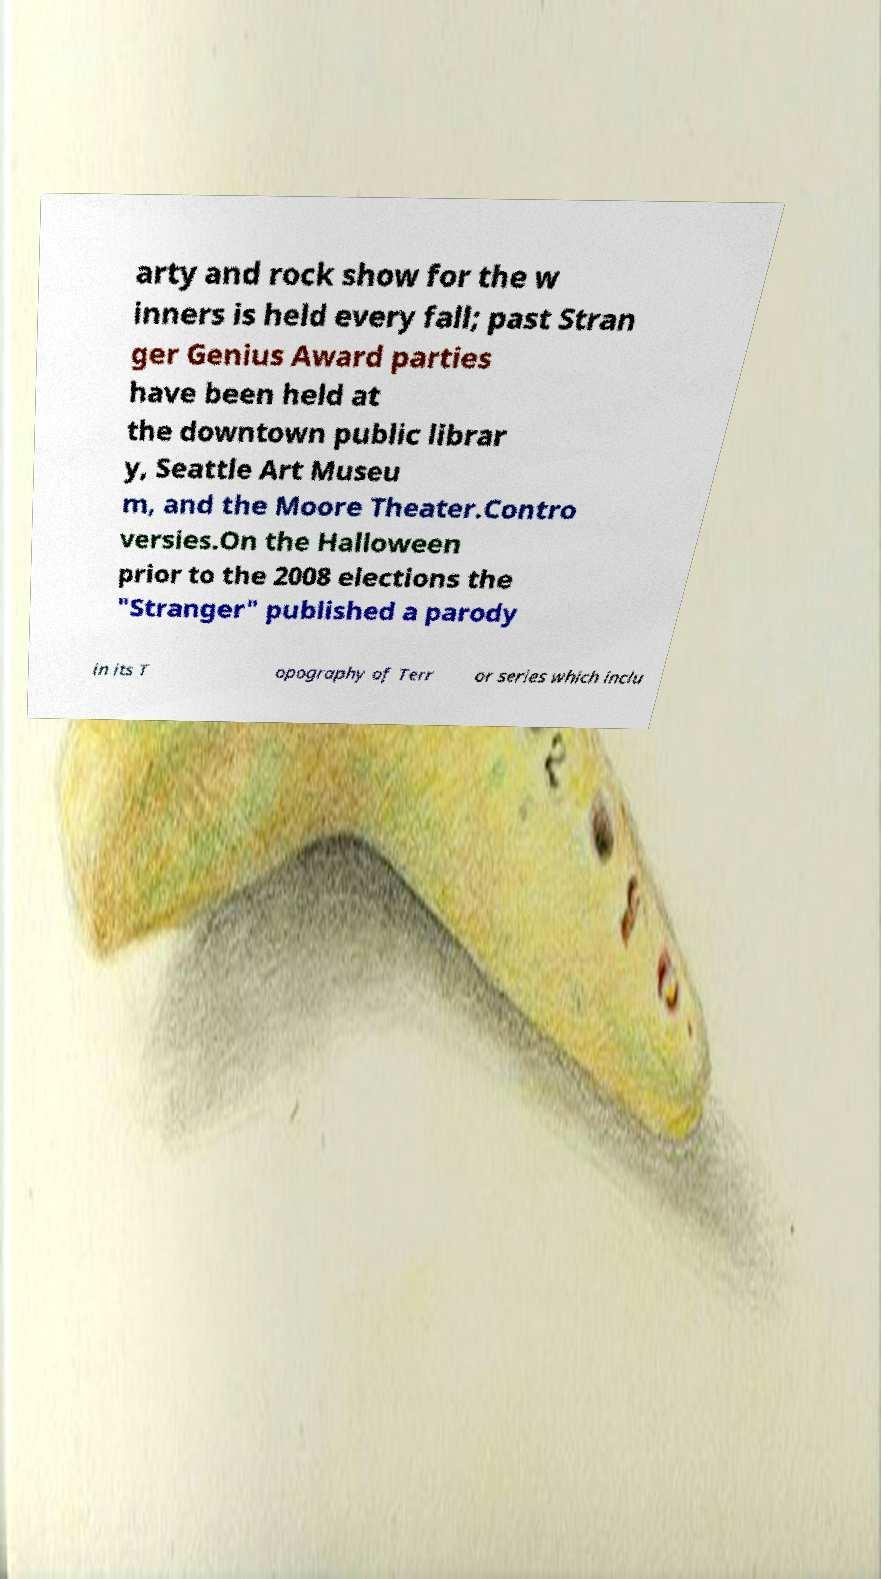I need the written content from this picture converted into text. Can you do that? arty and rock show for the w inners is held every fall; past Stran ger Genius Award parties have been held at the downtown public librar y, Seattle Art Museu m, and the Moore Theater.Contro versies.On the Halloween prior to the 2008 elections the "Stranger" published a parody in its T opography of Terr or series which inclu 